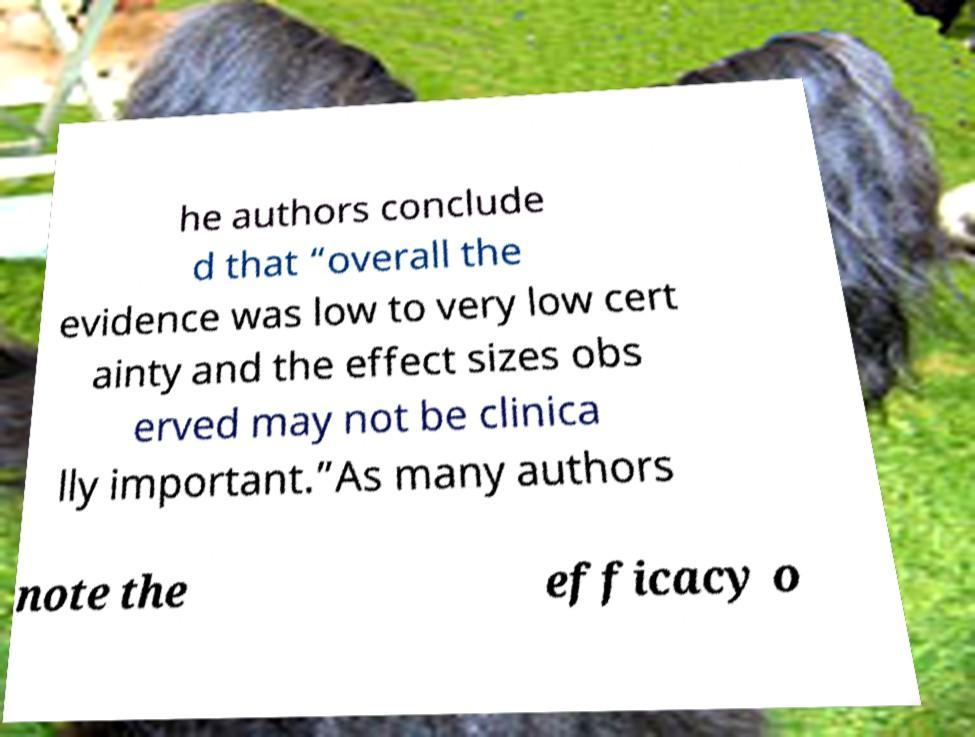Can you accurately transcribe the text from the provided image for me? he authors conclude d that “overall the evidence was low to very low cert ainty and the effect sizes obs erved may not be clinica lly important.”As many authors note the efficacy o 